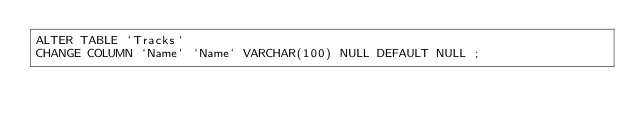<code> <loc_0><loc_0><loc_500><loc_500><_SQL_>ALTER TABLE `Tracks` 
CHANGE COLUMN `Name` `Name` VARCHAR(100) NULL DEFAULT NULL ;
</code> 